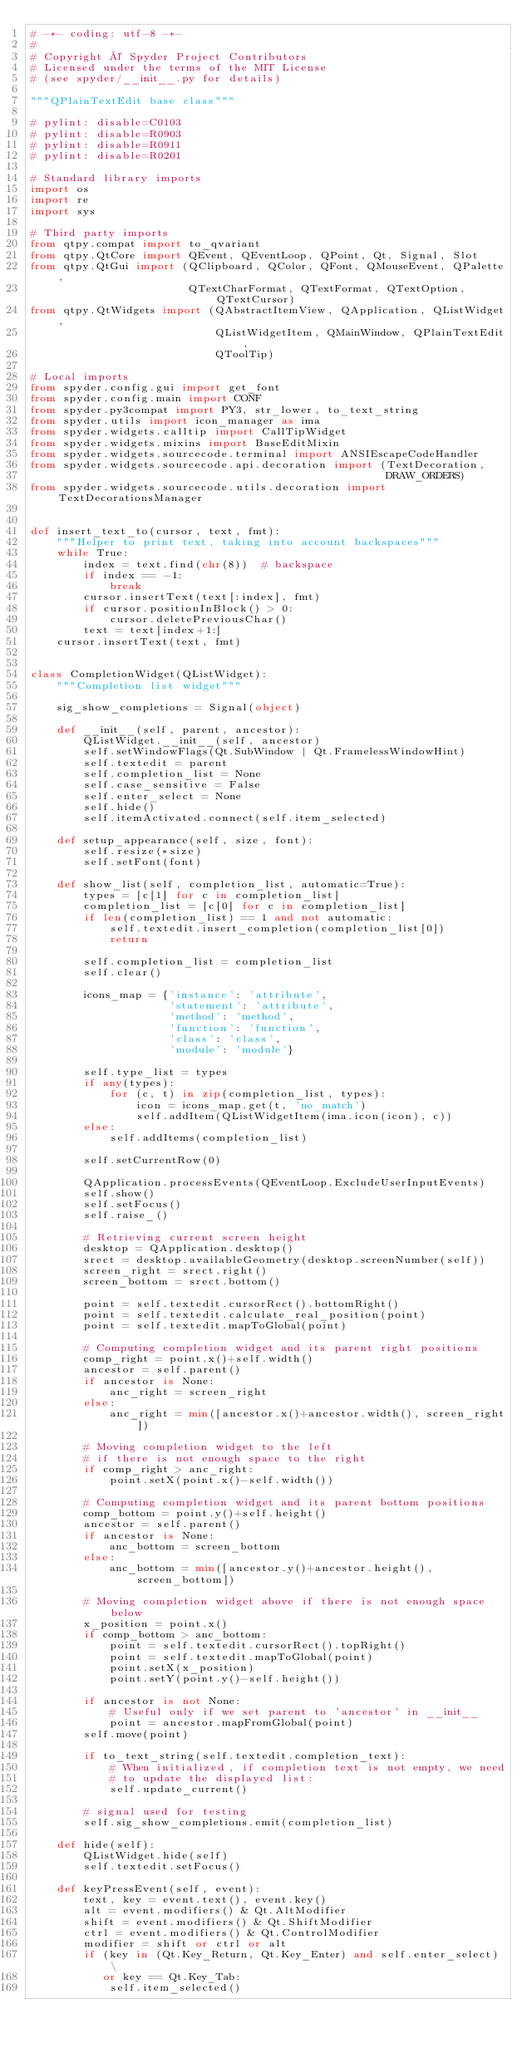Convert code to text. <code><loc_0><loc_0><loc_500><loc_500><_Python_># -*- coding: utf-8 -*-
#
# Copyright © Spyder Project Contributors
# Licensed under the terms of the MIT License
# (see spyder/__init__.py for details)

"""QPlainTextEdit base class"""

# pylint: disable=C0103
# pylint: disable=R0903
# pylint: disable=R0911
# pylint: disable=R0201

# Standard library imports
import os
import re
import sys

# Third party imports
from qtpy.compat import to_qvariant
from qtpy.QtCore import QEvent, QEventLoop, QPoint, Qt, Signal, Slot
from qtpy.QtGui import (QClipboard, QColor, QFont, QMouseEvent, QPalette,
                        QTextCharFormat, QTextFormat, QTextOption, QTextCursor)
from qtpy.QtWidgets import (QAbstractItemView, QApplication, QListWidget,
                            QListWidgetItem, QMainWindow, QPlainTextEdit,
                            QToolTip)

# Local imports
from spyder.config.gui import get_font
from spyder.config.main import CONF
from spyder.py3compat import PY3, str_lower, to_text_string
from spyder.utils import icon_manager as ima
from spyder.widgets.calltip import CallTipWidget
from spyder.widgets.mixins import BaseEditMixin
from spyder.widgets.sourcecode.terminal import ANSIEscapeCodeHandler
from spyder.widgets.sourcecode.api.decoration import (TextDecoration,
                                                      DRAW_ORDERS)
from spyder.widgets.sourcecode.utils.decoration import TextDecorationsManager


def insert_text_to(cursor, text, fmt):
    """Helper to print text, taking into account backspaces"""
    while True:
        index = text.find(chr(8))  # backspace
        if index == -1:
            break
        cursor.insertText(text[:index], fmt)
        if cursor.positionInBlock() > 0:
            cursor.deletePreviousChar()
        text = text[index+1:]
    cursor.insertText(text, fmt)


class CompletionWidget(QListWidget):
    """Completion list widget"""

    sig_show_completions = Signal(object)

    def __init__(self, parent, ancestor):
        QListWidget.__init__(self, ancestor)
        self.setWindowFlags(Qt.SubWindow | Qt.FramelessWindowHint)
        self.textedit = parent
        self.completion_list = None
        self.case_sensitive = False
        self.enter_select = None
        self.hide()
        self.itemActivated.connect(self.item_selected)
        
    def setup_appearance(self, size, font):
        self.resize(*size)
        self.setFont(font)
        
    def show_list(self, completion_list, automatic=True):
        types = [c[1] for c in completion_list]
        completion_list = [c[0] for c in completion_list]
        if len(completion_list) == 1 and not automatic:
            self.textedit.insert_completion(completion_list[0])
            return

        self.completion_list = completion_list
        self.clear()

        icons_map = {'instance': 'attribute',
                     'statement': 'attribute',
                     'method': 'method',
                     'function': 'function',
                     'class': 'class',
                     'module': 'module'}

        self.type_list = types
        if any(types):
            for (c, t) in zip(completion_list, types):
                icon = icons_map.get(t, 'no_match')
                self.addItem(QListWidgetItem(ima.icon(icon), c))
        else:
            self.addItems(completion_list)

        self.setCurrentRow(0)

        QApplication.processEvents(QEventLoop.ExcludeUserInputEvents)
        self.show()
        self.setFocus()
        self.raise_()
        
        # Retrieving current screen height
        desktop = QApplication.desktop()
        srect = desktop.availableGeometry(desktop.screenNumber(self))
        screen_right = srect.right()
        screen_bottom = srect.bottom()
        
        point = self.textedit.cursorRect().bottomRight()
        point = self.textedit.calculate_real_position(point)
        point = self.textedit.mapToGlobal(point)

        # Computing completion widget and its parent right positions
        comp_right = point.x()+self.width()
        ancestor = self.parent()
        if ancestor is None:
            anc_right = screen_right
        else:
            anc_right = min([ancestor.x()+ancestor.width(), screen_right])
        
        # Moving completion widget to the left
        # if there is not enough space to the right
        if comp_right > anc_right:
            point.setX(point.x()-self.width())
        
        # Computing completion widget and its parent bottom positions
        comp_bottom = point.y()+self.height()
        ancestor = self.parent()
        if ancestor is None:
            anc_bottom = screen_bottom
        else:
            anc_bottom = min([ancestor.y()+ancestor.height(), screen_bottom])
        
        # Moving completion widget above if there is not enough space below
        x_position = point.x()
        if comp_bottom > anc_bottom:
            point = self.textedit.cursorRect().topRight()
            point = self.textedit.mapToGlobal(point)
            point.setX(x_position)
            point.setY(point.y()-self.height())
            
        if ancestor is not None:
            # Useful only if we set parent to 'ancestor' in __init__
            point = ancestor.mapFromGlobal(point)
        self.move(point)
        
        if to_text_string(self.textedit.completion_text):
            # When initialized, if completion text is not empty, we need 
            # to update the displayed list:
            self.update_current()
        
        # signal used for testing
        self.sig_show_completions.emit(completion_list)

    def hide(self):
        QListWidget.hide(self)
        self.textedit.setFocus()
        
    def keyPressEvent(self, event):
        text, key = event.text(), event.key()
        alt = event.modifiers() & Qt.AltModifier
        shift = event.modifiers() & Qt.ShiftModifier
        ctrl = event.modifiers() & Qt.ControlModifier
        modifier = shift or ctrl or alt
        if (key in (Qt.Key_Return, Qt.Key_Enter) and self.enter_select) \
           or key == Qt.Key_Tab:
            self.item_selected()</code> 